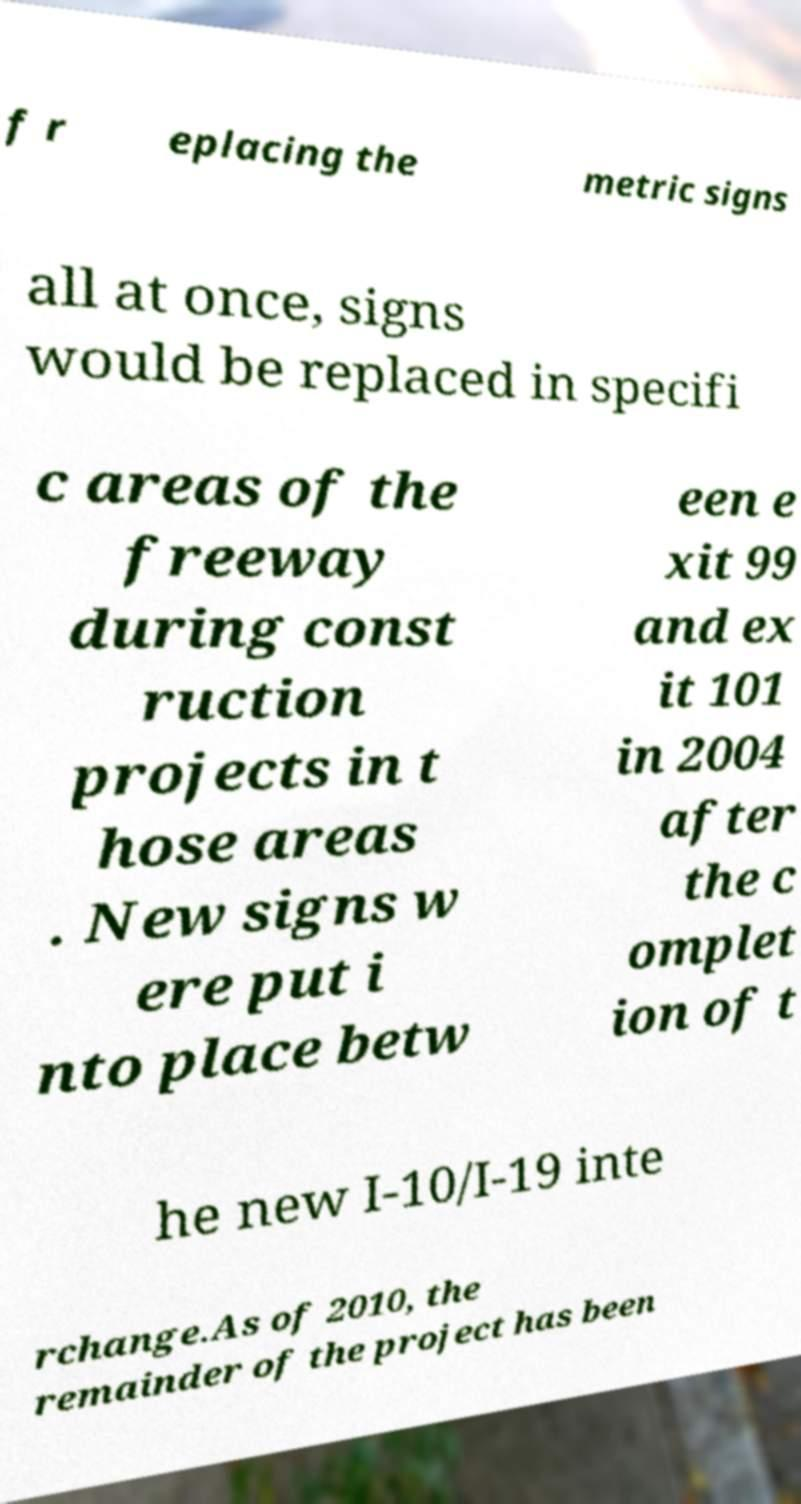Please read and relay the text visible in this image. What does it say? f r eplacing the metric signs all at once, signs would be replaced in specifi c areas of the freeway during const ruction projects in t hose areas . New signs w ere put i nto place betw een e xit 99 and ex it 101 in 2004 after the c omplet ion of t he new I-10/I-19 inte rchange.As of 2010, the remainder of the project has been 